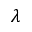<formula> <loc_0><loc_0><loc_500><loc_500>\lambda</formula> 